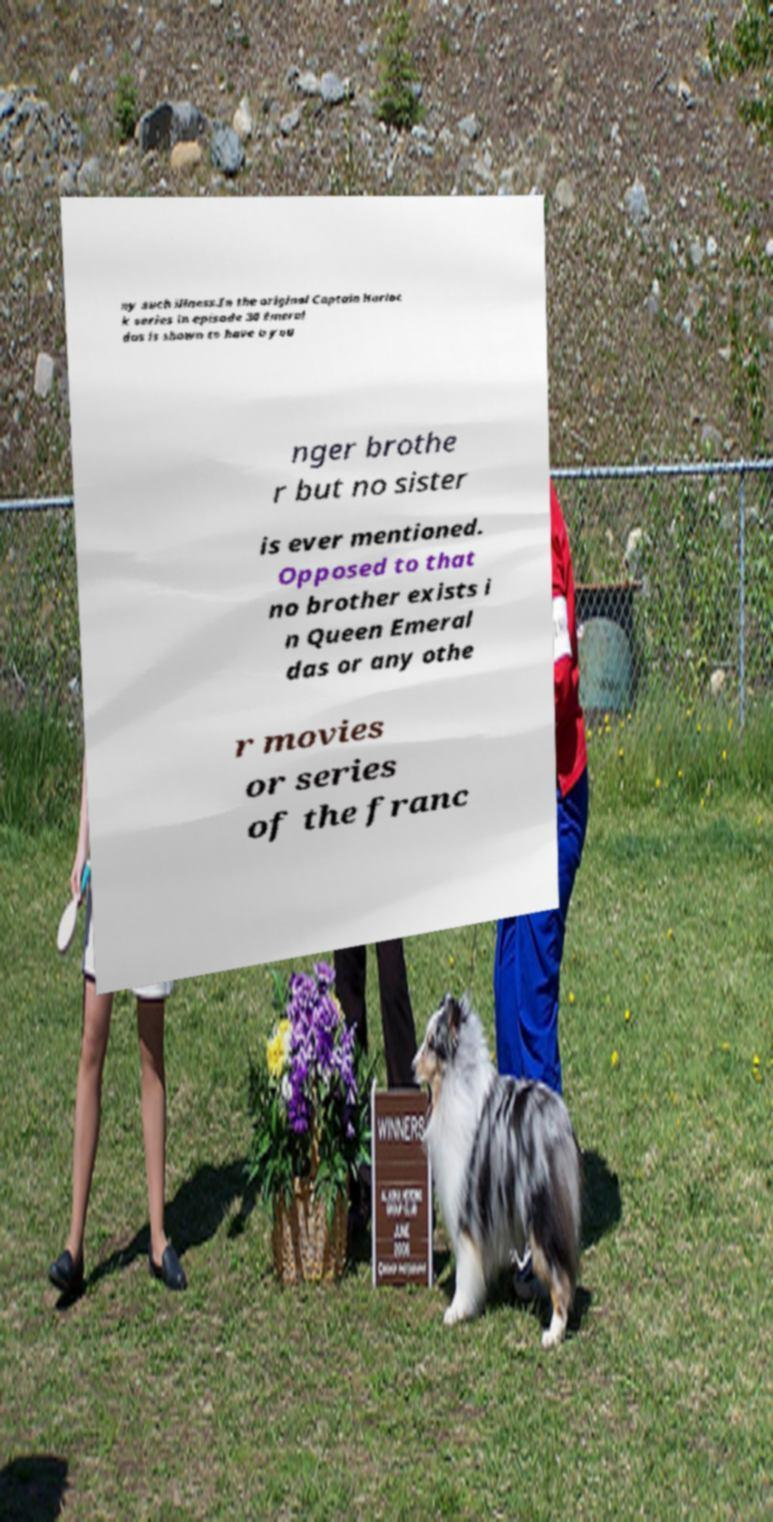I need the written content from this picture converted into text. Can you do that? ny such illness.In the original Captain Harloc k series in episode 30 Emeral das is shown to have a you nger brothe r but no sister is ever mentioned. Opposed to that no brother exists i n Queen Emeral das or any othe r movies or series of the franc 